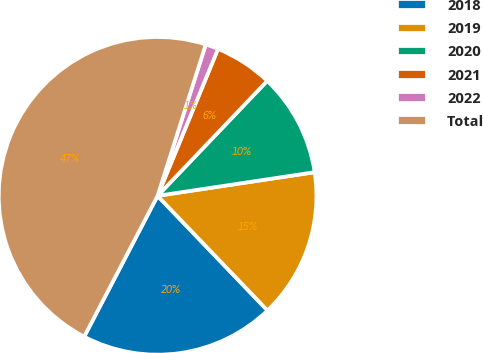Convert chart. <chart><loc_0><loc_0><loc_500><loc_500><pie_chart><fcel>2018<fcel>2019<fcel>2020<fcel>2021<fcel>2022<fcel>Total<nl><fcel>19.81%<fcel>15.21%<fcel>10.5%<fcel>5.91%<fcel>1.31%<fcel>47.26%<nl></chart> 